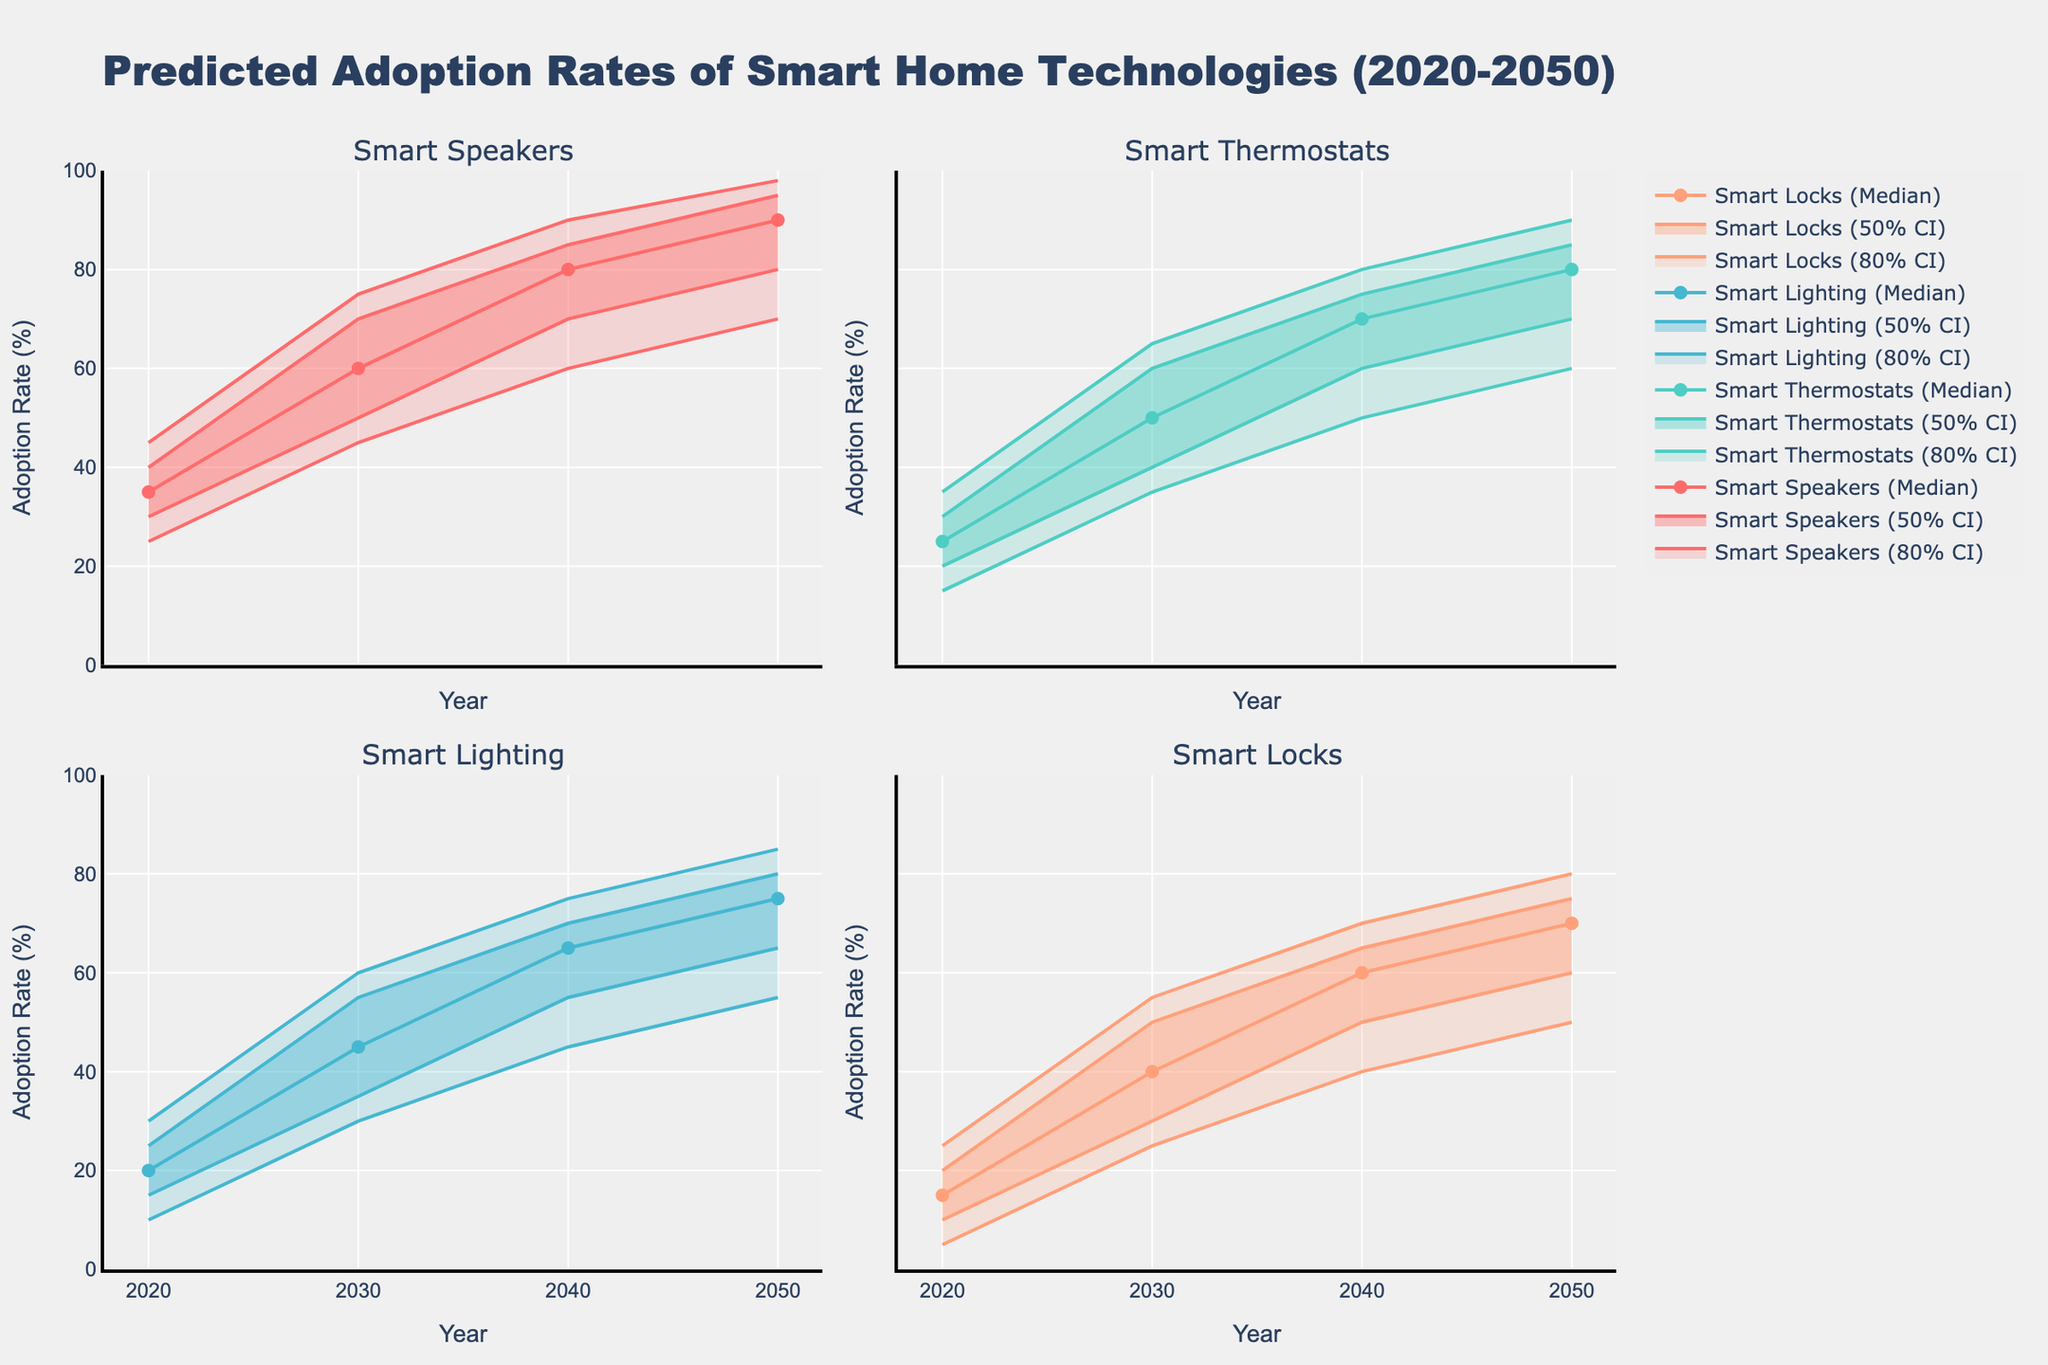What is the median predicted adoption rate of Smart Speakers in 2030? The median predicted adoption rate of Smart Speakers in 2030 can be found directly in the table or figure which shows the values for each year and technology. For Smart Speakers in 2030, the median value is listed.
Answer: 60 What is the range of adoption rates for Smart Thermostats in 2050 within the 50% confidence interval? The 50% confidence interval is the range between the Lower 25% and Upper 25% values. For Smart Thermostats in 2050, this interval is from 70% to 85%. The range is calculated by subtracting the lower value from the upper value: 85 - 70 = 15.
Answer: 15 Which smart home technology is predicted to have the highest median adoption rate in 2040? By comparing the median adoption rates of all technologies in 2040, we can determine that Smart Speakers have the highest median rate.
Answer: Smart Speakers How does the upper 90% predicted adoption rate of Smart Locks in 2040 compare with the lower 10% predicted rate of Smart Speakers in the same year? The upper 90% adoption rate for Smart Locks in 2040 is 70%, while the lower 10% adoption rate for Smart Speakers in the same year is 60%. Comparing these two values shows that the upper 90% rate of Smart Locks is higher.
Answer: Higher What is the average median predicted adoption rate of all technologies in 2050? To find the average, we sum the median predicted adoption rates of all technologies in 2050 and divide by the number of technologies. (90 + 80 + 75 + 70) / 4 = 315 / 4 = 78.75
Answer: 78.75 Which technology shows the biggest increase in median adoption rate from 2020 to 2050? By comparing the median adoption rates for each technology in 2020 and 2050, we can identify the technology with the greatest increase. Smart Speakers increase from 35% to 90%, which is an increase of 55 percentage points.
Answer: Smart Speakers How does the predicted adoption rate of Smart Lighting in 2030 within the 80% confidence interval compare to that in 2040? The 80% confidence interval spans from the Lower 10% to Upper 90%. For Smart Lighting, in 2030 it is 30% to 60%, and in 2040 it is 45% to 75%. The intervals are both higher in 2040 compared to 2030.
Answer: Higher What are the predicted upper 25% adoption rates for Smart Thermostats in 2040 and 2050, and how do they compare? The upper 25% adoption rate for Smart Thermostats in 2040 is 75%, and in 2050 it is 85%. Comparing these values shows that the rate is higher in 2050.
Answer: Higher in 2050 How does the lower 25% predicted adoption rate of Smart Lighting in 2040 compare with the upper 90% predicted rate of Smart Locks in 2020? The lower 25% rate for Smart Lighting in 2040 is 55%, while the upper 90% rate for Smart Locks in 2020 is 25%. The rate for Smart Lighting in 2040 is higher.
Answer: Higher What trend can be observed in the adoption rates of Smart Speakers from 2020 to 2050? Observing the median values for Smart Speakers from 2020 to 2050, we can see a steadily increasing trend in adoption rates from 35% in 2020 to 90% in 2050.
Answer: Increasing 